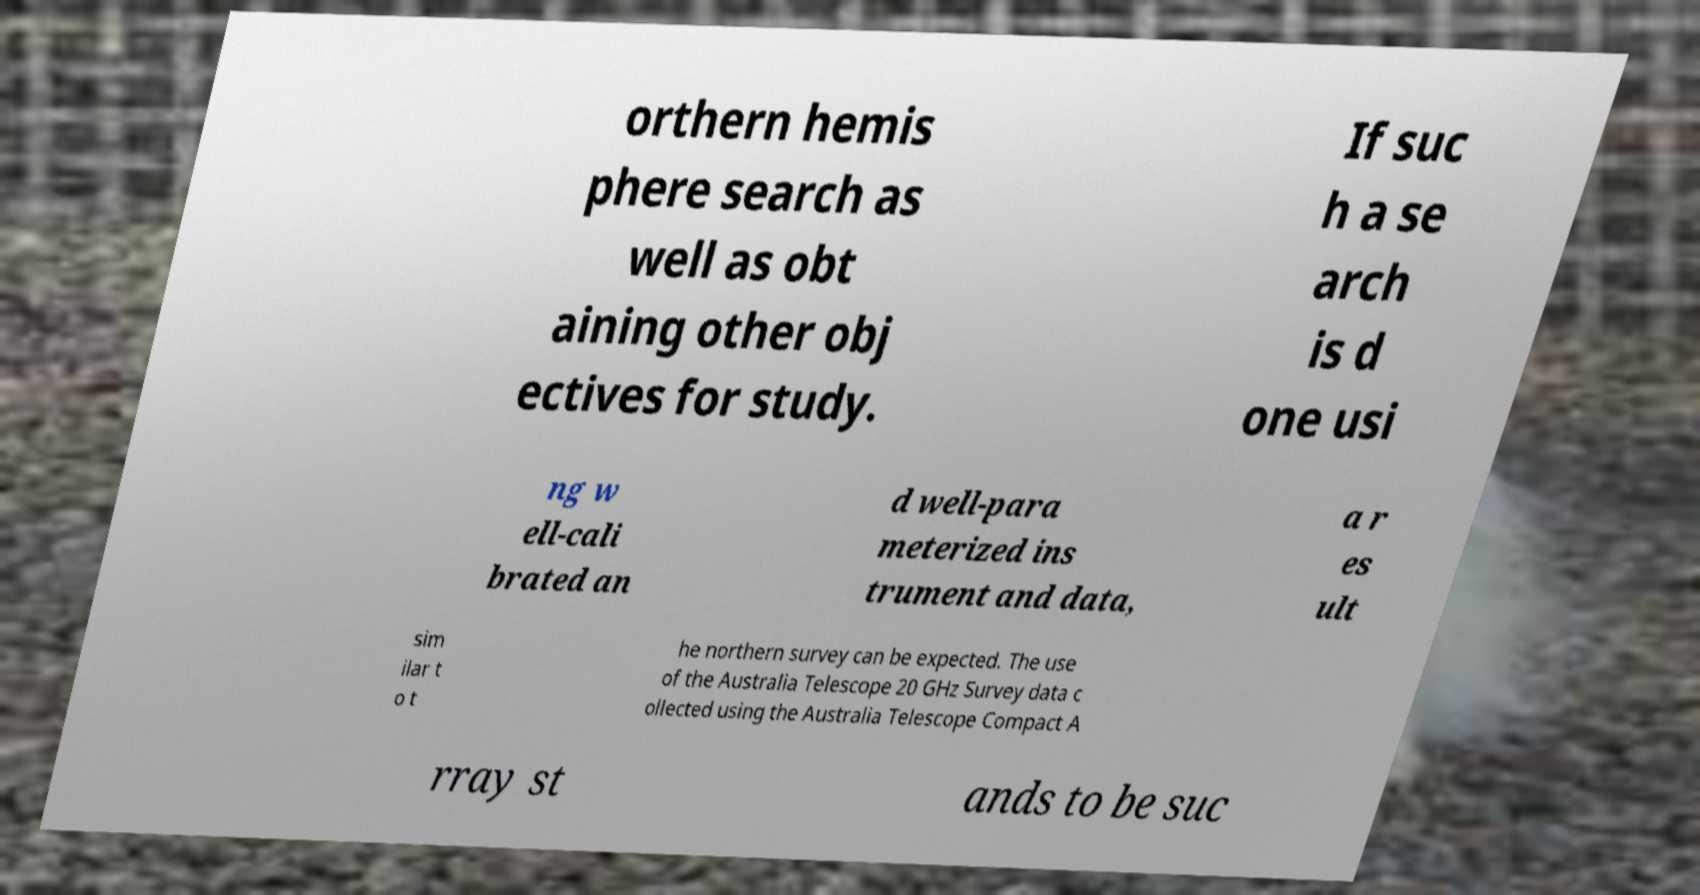What messages or text are displayed in this image? I need them in a readable, typed format. orthern hemis phere search as well as obt aining other obj ectives for study. If suc h a se arch is d one usi ng w ell-cali brated an d well-para meterized ins trument and data, a r es ult sim ilar t o t he northern survey can be expected. The use of the Australia Telescope 20 GHz Survey data c ollected using the Australia Telescope Compact A rray st ands to be suc 